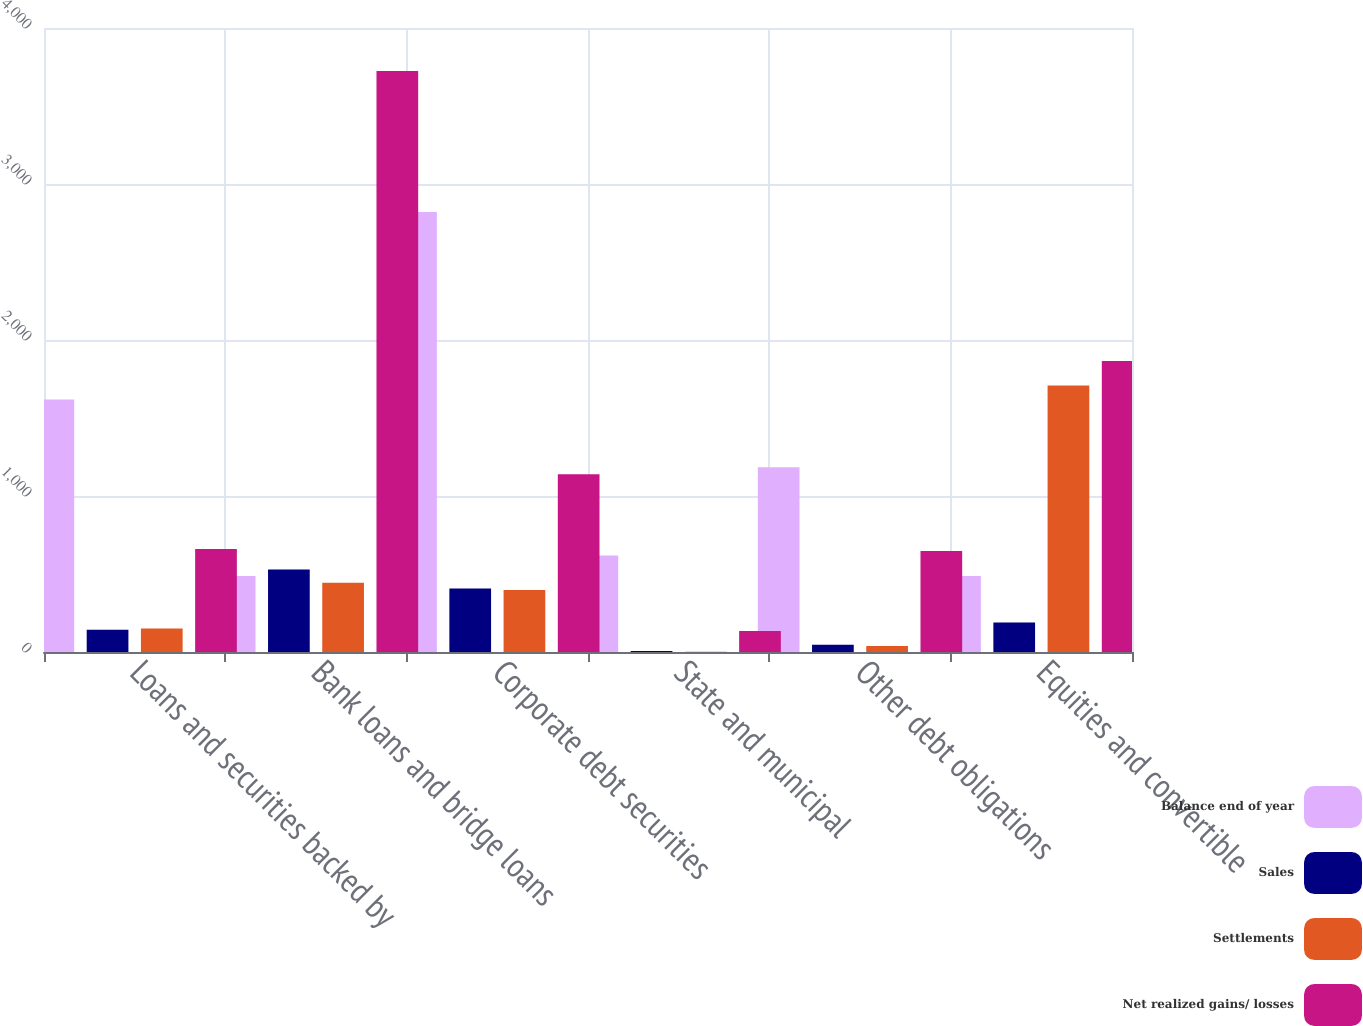Convert chart. <chart><loc_0><loc_0><loc_500><loc_500><stacked_bar_chart><ecel><fcel>Loans and securities backed by<fcel>Bank loans and bridge loans<fcel>Corporate debt securities<fcel>State and municipal<fcel>Other debt obligations<fcel>Equities and convertible<nl><fcel>Balance end of year<fcel>1619<fcel>486.5<fcel>2821<fcel>619<fcel>1185<fcel>486.5<nl><fcel>Sales<fcel>143<fcel>529<fcel>407<fcel>6<fcel>47<fcel>189<nl><fcel>Settlements<fcel>150<fcel>444<fcel>398<fcel>2<fcel>38<fcel>1709<nl><fcel>Net realized gains/ losses<fcel>660<fcel>3725<fcel>1140<fcel>134<fcel>648<fcel>1866<nl></chart> 